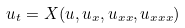<formula> <loc_0><loc_0><loc_500><loc_500>u _ { t } = X ( u , u _ { x } , u _ { x x } , u _ { x x x } )</formula> 